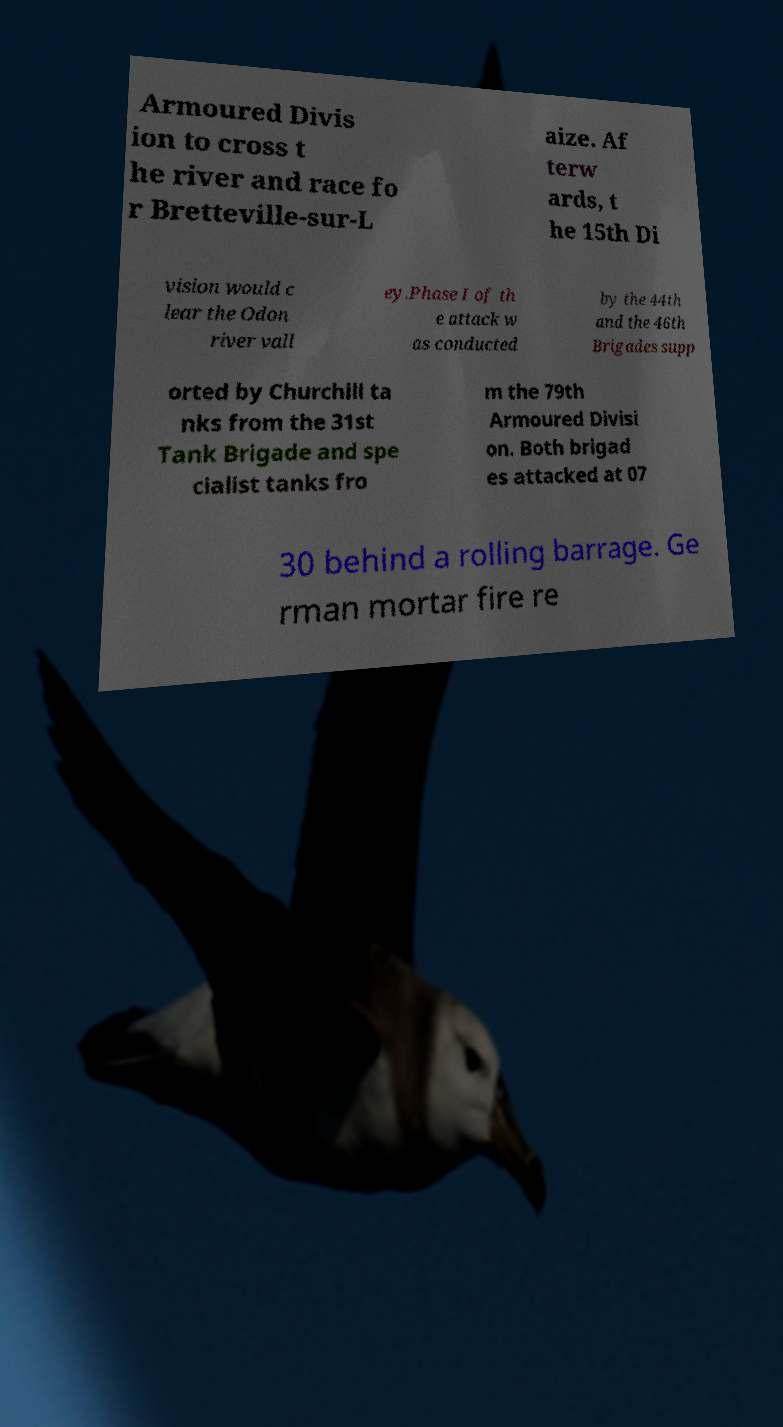Can you read and provide the text displayed in the image?This photo seems to have some interesting text. Can you extract and type it out for me? Armoured Divis ion to cross t he river and race fo r Bretteville-sur-L aize. Af terw ards, t he 15th Di vision would c lear the Odon river vall ey.Phase I of th e attack w as conducted by the 44th and the 46th Brigades supp orted by Churchill ta nks from the 31st Tank Brigade and spe cialist tanks fro m the 79th Armoured Divisi on. Both brigad es attacked at 07 30 behind a rolling barrage. Ge rman mortar fire re 